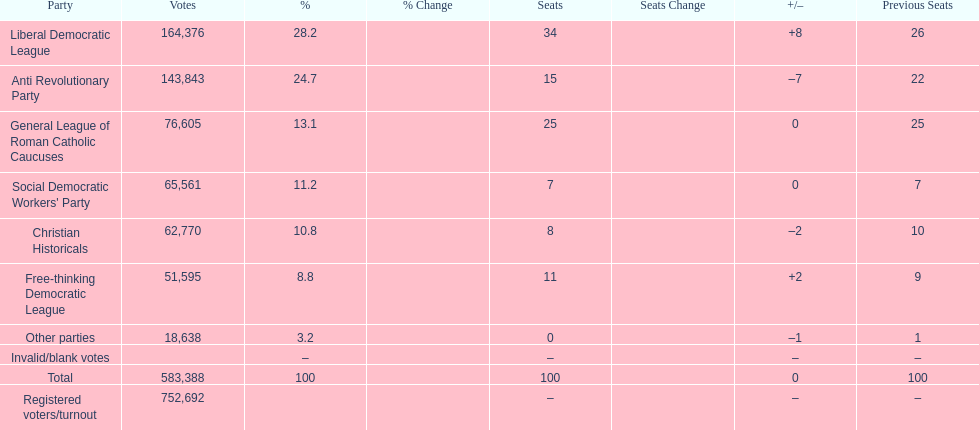How many more votes did the liberal democratic league win over the free-thinking democratic league? 112,781. 